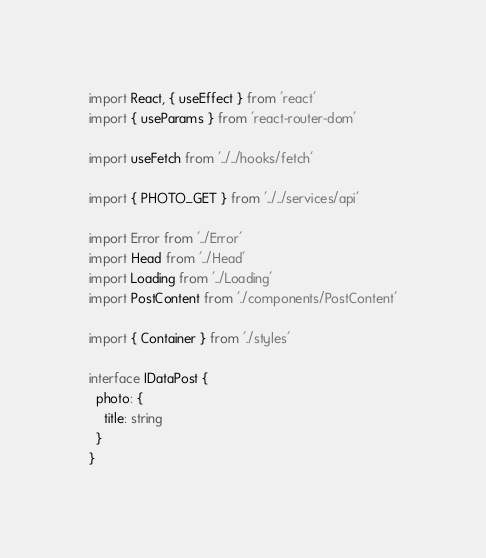Convert code to text. <code><loc_0><loc_0><loc_500><loc_500><_TypeScript_>import React, { useEffect } from 'react'
import { useParams } from 'react-router-dom'

import useFetch from '../../hooks/fetch'

import { PHOTO_GET } from '../../services/api'

import Error from '../Error'
import Head from '../Head'
import Loading from '../Loading'
import PostContent from './components/PostContent'

import { Container } from './styles'

interface IDataPost {
  photo: {
    title: string
  }
}
</code> 